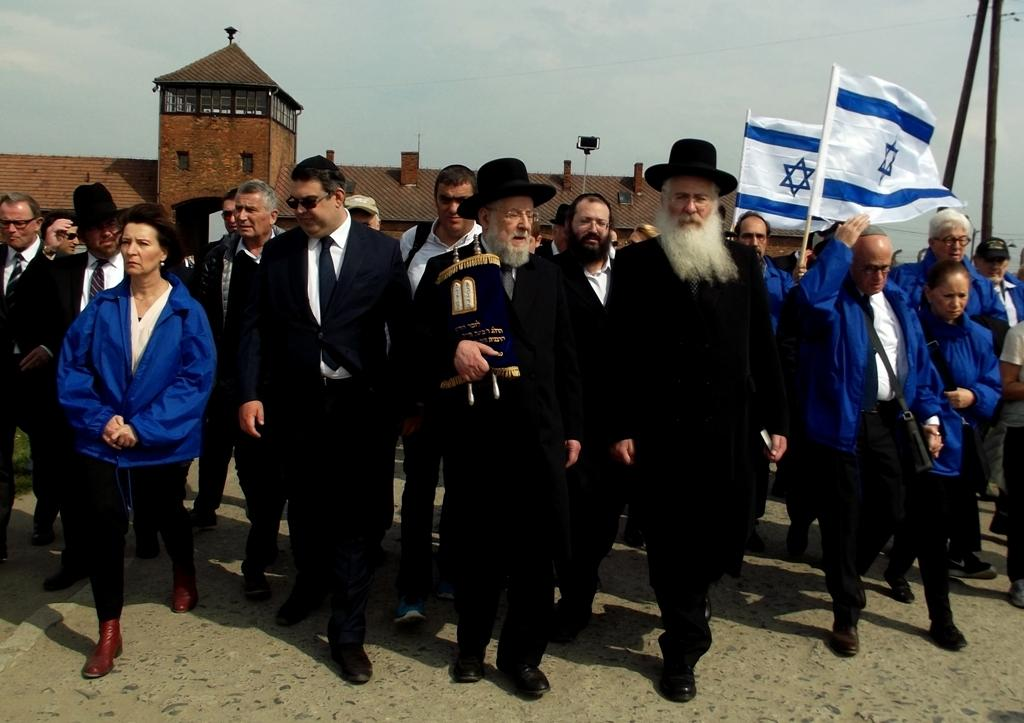What are the people in the image doing? There is a group of people walking on the road. Can you describe the people on the right side of the image? There are people holding flags on the right side. What can be seen in the background of the image? There is a building in the background. What type of dinosaurs can be seen walking alongside the people in the image? There are no dinosaurs present in the image; it features a group of people walking on the road and holding flags. Is there a crib visible in the image? There is no crib present in the image. 